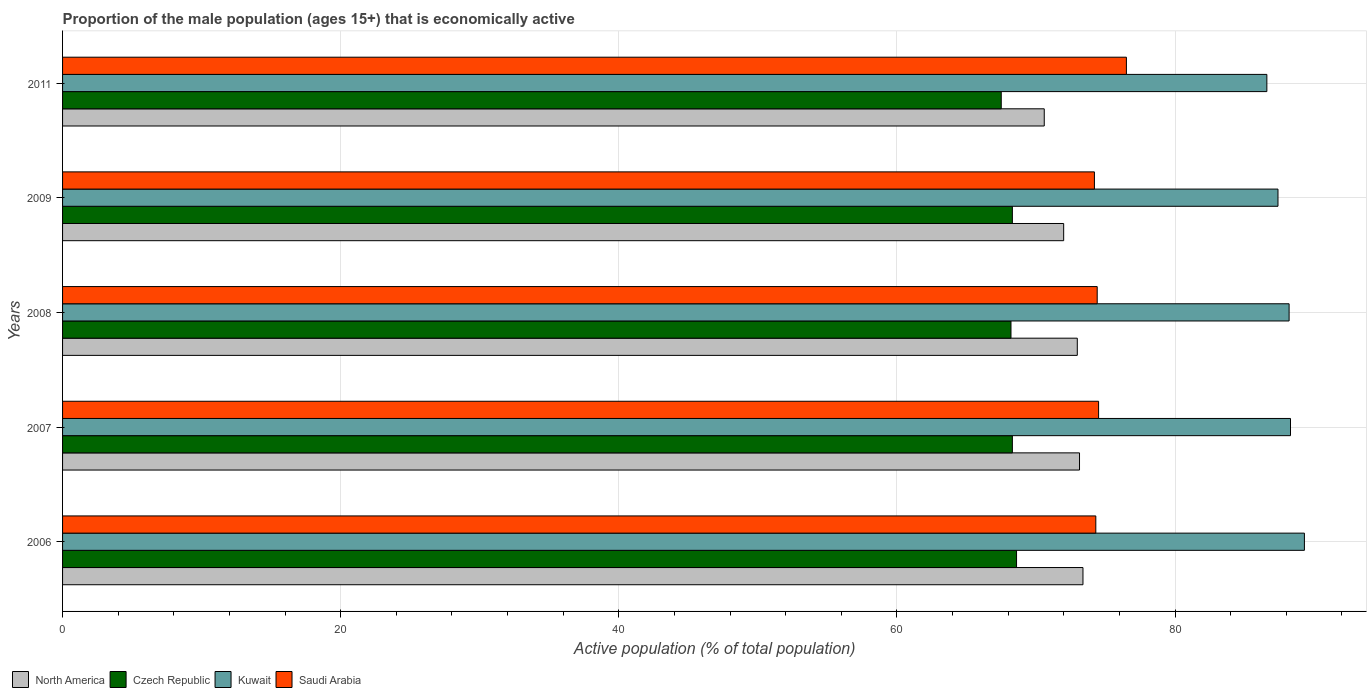How many groups of bars are there?
Offer a terse response. 5. Are the number of bars per tick equal to the number of legend labels?
Make the answer very short. Yes. How many bars are there on the 4th tick from the bottom?
Make the answer very short. 4. In how many cases, is the number of bars for a given year not equal to the number of legend labels?
Offer a very short reply. 0. What is the proportion of the male population that is economically active in Kuwait in 2006?
Offer a terse response. 89.3. Across all years, what is the maximum proportion of the male population that is economically active in Saudi Arabia?
Give a very brief answer. 76.5. Across all years, what is the minimum proportion of the male population that is economically active in Czech Republic?
Provide a short and direct response. 67.5. In which year was the proportion of the male population that is economically active in Saudi Arabia maximum?
Your response must be concise. 2011. What is the total proportion of the male population that is economically active in North America in the graph?
Your answer should be compact. 362.06. What is the difference between the proportion of the male population that is economically active in Czech Republic in 2007 and that in 2008?
Ensure brevity in your answer.  0.1. What is the difference between the proportion of the male population that is economically active in Czech Republic in 2006 and the proportion of the male population that is economically active in Kuwait in 2009?
Offer a very short reply. -18.8. What is the average proportion of the male population that is economically active in North America per year?
Give a very brief answer. 72.41. In the year 2008, what is the difference between the proportion of the male population that is economically active in Kuwait and proportion of the male population that is economically active in North America?
Provide a succinct answer. 15.23. In how many years, is the proportion of the male population that is economically active in Czech Republic greater than 44 %?
Make the answer very short. 5. What is the ratio of the proportion of the male population that is economically active in Kuwait in 2006 to that in 2008?
Offer a terse response. 1.01. What is the difference between the highest and the second highest proportion of the male population that is economically active in Saudi Arabia?
Give a very brief answer. 2. What is the difference between the highest and the lowest proportion of the male population that is economically active in Czech Republic?
Ensure brevity in your answer.  1.1. In how many years, is the proportion of the male population that is economically active in Saudi Arabia greater than the average proportion of the male population that is economically active in Saudi Arabia taken over all years?
Your answer should be very brief. 1. Is the sum of the proportion of the male population that is economically active in North America in 2008 and 2011 greater than the maximum proportion of the male population that is economically active in Czech Republic across all years?
Provide a succinct answer. Yes. Is it the case that in every year, the sum of the proportion of the male population that is economically active in North America and proportion of the male population that is economically active in Czech Republic is greater than the sum of proportion of the male population that is economically active in Kuwait and proportion of the male population that is economically active in Saudi Arabia?
Make the answer very short. No. What does the 3rd bar from the top in 2009 represents?
Offer a very short reply. Czech Republic. What does the 4th bar from the bottom in 2009 represents?
Make the answer very short. Saudi Arabia. Are all the bars in the graph horizontal?
Your answer should be very brief. Yes. Are the values on the major ticks of X-axis written in scientific E-notation?
Provide a succinct answer. No. Does the graph contain grids?
Make the answer very short. Yes. Where does the legend appear in the graph?
Make the answer very short. Bottom left. How many legend labels are there?
Your response must be concise. 4. What is the title of the graph?
Keep it short and to the point. Proportion of the male population (ages 15+) that is economically active. What is the label or title of the X-axis?
Ensure brevity in your answer.  Active population (% of total population). What is the Active population (% of total population) in North America in 2006?
Provide a short and direct response. 73.38. What is the Active population (% of total population) of Czech Republic in 2006?
Give a very brief answer. 68.6. What is the Active population (% of total population) of Kuwait in 2006?
Offer a terse response. 89.3. What is the Active population (% of total population) in Saudi Arabia in 2006?
Give a very brief answer. 74.3. What is the Active population (% of total population) of North America in 2007?
Provide a short and direct response. 73.13. What is the Active population (% of total population) of Czech Republic in 2007?
Give a very brief answer. 68.3. What is the Active population (% of total population) of Kuwait in 2007?
Ensure brevity in your answer.  88.3. What is the Active population (% of total population) of Saudi Arabia in 2007?
Keep it short and to the point. 74.5. What is the Active population (% of total population) in North America in 2008?
Provide a succinct answer. 72.97. What is the Active population (% of total population) of Czech Republic in 2008?
Your answer should be very brief. 68.2. What is the Active population (% of total population) in Kuwait in 2008?
Make the answer very short. 88.2. What is the Active population (% of total population) of Saudi Arabia in 2008?
Your answer should be compact. 74.4. What is the Active population (% of total population) of North America in 2009?
Make the answer very short. 71.99. What is the Active population (% of total population) in Czech Republic in 2009?
Your answer should be compact. 68.3. What is the Active population (% of total population) in Kuwait in 2009?
Offer a very short reply. 87.4. What is the Active population (% of total population) in Saudi Arabia in 2009?
Your answer should be very brief. 74.2. What is the Active population (% of total population) of North America in 2011?
Keep it short and to the point. 70.59. What is the Active population (% of total population) of Czech Republic in 2011?
Offer a terse response. 67.5. What is the Active population (% of total population) in Kuwait in 2011?
Offer a terse response. 86.6. What is the Active population (% of total population) in Saudi Arabia in 2011?
Your response must be concise. 76.5. Across all years, what is the maximum Active population (% of total population) of North America?
Your answer should be compact. 73.38. Across all years, what is the maximum Active population (% of total population) in Czech Republic?
Keep it short and to the point. 68.6. Across all years, what is the maximum Active population (% of total population) of Kuwait?
Offer a terse response. 89.3. Across all years, what is the maximum Active population (% of total population) in Saudi Arabia?
Make the answer very short. 76.5. Across all years, what is the minimum Active population (% of total population) in North America?
Your answer should be very brief. 70.59. Across all years, what is the minimum Active population (% of total population) in Czech Republic?
Your response must be concise. 67.5. Across all years, what is the minimum Active population (% of total population) in Kuwait?
Provide a succinct answer. 86.6. Across all years, what is the minimum Active population (% of total population) in Saudi Arabia?
Give a very brief answer. 74.2. What is the total Active population (% of total population) in North America in the graph?
Give a very brief answer. 362.06. What is the total Active population (% of total population) of Czech Republic in the graph?
Offer a very short reply. 340.9. What is the total Active population (% of total population) of Kuwait in the graph?
Keep it short and to the point. 439.8. What is the total Active population (% of total population) in Saudi Arabia in the graph?
Provide a succinct answer. 373.9. What is the difference between the Active population (% of total population) of North America in 2006 and that in 2007?
Ensure brevity in your answer.  0.25. What is the difference between the Active population (% of total population) in Saudi Arabia in 2006 and that in 2007?
Provide a succinct answer. -0.2. What is the difference between the Active population (% of total population) in North America in 2006 and that in 2008?
Provide a short and direct response. 0.41. What is the difference between the Active population (% of total population) of Kuwait in 2006 and that in 2008?
Provide a succinct answer. 1.1. What is the difference between the Active population (% of total population) in Saudi Arabia in 2006 and that in 2008?
Provide a succinct answer. -0.1. What is the difference between the Active population (% of total population) of North America in 2006 and that in 2009?
Your response must be concise. 1.39. What is the difference between the Active population (% of total population) of Czech Republic in 2006 and that in 2009?
Your answer should be very brief. 0.3. What is the difference between the Active population (% of total population) of North America in 2006 and that in 2011?
Provide a succinct answer. 2.78. What is the difference between the Active population (% of total population) in Czech Republic in 2006 and that in 2011?
Provide a short and direct response. 1.1. What is the difference between the Active population (% of total population) of Saudi Arabia in 2006 and that in 2011?
Your response must be concise. -2.2. What is the difference between the Active population (% of total population) in North America in 2007 and that in 2008?
Your answer should be very brief. 0.16. What is the difference between the Active population (% of total population) of Czech Republic in 2007 and that in 2008?
Provide a short and direct response. 0.1. What is the difference between the Active population (% of total population) in Saudi Arabia in 2007 and that in 2008?
Keep it short and to the point. 0.1. What is the difference between the Active population (% of total population) of North America in 2007 and that in 2009?
Offer a terse response. 1.14. What is the difference between the Active population (% of total population) in Czech Republic in 2007 and that in 2009?
Your answer should be compact. 0. What is the difference between the Active population (% of total population) in Kuwait in 2007 and that in 2009?
Your response must be concise. 0.9. What is the difference between the Active population (% of total population) in North America in 2007 and that in 2011?
Make the answer very short. 2.54. What is the difference between the Active population (% of total population) in North America in 2008 and that in 2009?
Your answer should be very brief. 0.98. What is the difference between the Active population (% of total population) of Saudi Arabia in 2008 and that in 2009?
Your answer should be very brief. 0.2. What is the difference between the Active population (% of total population) of North America in 2008 and that in 2011?
Offer a very short reply. 2.38. What is the difference between the Active population (% of total population) of Saudi Arabia in 2008 and that in 2011?
Make the answer very short. -2.1. What is the difference between the Active population (% of total population) in North America in 2009 and that in 2011?
Offer a terse response. 1.4. What is the difference between the Active population (% of total population) in North America in 2006 and the Active population (% of total population) in Czech Republic in 2007?
Your response must be concise. 5.08. What is the difference between the Active population (% of total population) of North America in 2006 and the Active population (% of total population) of Kuwait in 2007?
Your answer should be compact. -14.92. What is the difference between the Active population (% of total population) of North America in 2006 and the Active population (% of total population) of Saudi Arabia in 2007?
Give a very brief answer. -1.12. What is the difference between the Active population (% of total population) in Czech Republic in 2006 and the Active population (% of total population) in Kuwait in 2007?
Give a very brief answer. -19.7. What is the difference between the Active population (% of total population) in Czech Republic in 2006 and the Active population (% of total population) in Saudi Arabia in 2007?
Keep it short and to the point. -5.9. What is the difference between the Active population (% of total population) of Kuwait in 2006 and the Active population (% of total population) of Saudi Arabia in 2007?
Keep it short and to the point. 14.8. What is the difference between the Active population (% of total population) of North America in 2006 and the Active population (% of total population) of Czech Republic in 2008?
Your answer should be compact. 5.18. What is the difference between the Active population (% of total population) of North America in 2006 and the Active population (% of total population) of Kuwait in 2008?
Provide a short and direct response. -14.82. What is the difference between the Active population (% of total population) in North America in 2006 and the Active population (% of total population) in Saudi Arabia in 2008?
Provide a short and direct response. -1.02. What is the difference between the Active population (% of total population) in Czech Republic in 2006 and the Active population (% of total population) in Kuwait in 2008?
Provide a short and direct response. -19.6. What is the difference between the Active population (% of total population) in North America in 2006 and the Active population (% of total population) in Czech Republic in 2009?
Give a very brief answer. 5.08. What is the difference between the Active population (% of total population) of North America in 2006 and the Active population (% of total population) of Kuwait in 2009?
Make the answer very short. -14.02. What is the difference between the Active population (% of total population) in North America in 2006 and the Active population (% of total population) in Saudi Arabia in 2009?
Keep it short and to the point. -0.82. What is the difference between the Active population (% of total population) in Czech Republic in 2006 and the Active population (% of total population) in Kuwait in 2009?
Offer a very short reply. -18.8. What is the difference between the Active population (% of total population) in Kuwait in 2006 and the Active population (% of total population) in Saudi Arabia in 2009?
Keep it short and to the point. 15.1. What is the difference between the Active population (% of total population) of North America in 2006 and the Active population (% of total population) of Czech Republic in 2011?
Offer a terse response. 5.88. What is the difference between the Active population (% of total population) of North America in 2006 and the Active population (% of total population) of Kuwait in 2011?
Provide a short and direct response. -13.22. What is the difference between the Active population (% of total population) in North America in 2006 and the Active population (% of total population) in Saudi Arabia in 2011?
Your response must be concise. -3.12. What is the difference between the Active population (% of total population) of Czech Republic in 2006 and the Active population (% of total population) of Kuwait in 2011?
Offer a very short reply. -18. What is the difference between the Active population (% of total population) in Kuwait in 2006 and the Active population (% of total population) in Saudi Arabia in 2011?
Keep it short and to the point. 12.8. What is the difference between the Active population (% of total population) of North America in 2007 and the Active population (% of total population) of Czech Republic in 2008?
Give a very brief answer. 4.93. What is the difference between the Active population (% of total population) in North America in 2007 and the Active population (% of total population) in Kuwait in 2008?
Offer a terse response. -15.07. What is the difference between the Active population (% of total population) in North America in 2007 and the Active population (% of total population) in Saudi Arabia in 2008?
Your answer should be very brief. -1.27. What is the difference between the Active population (% of total population) of Czech Republic in 2007 and the Active population (% of total population) of Kuwait in 2008?
Keep it short and to the point. -19.9. What is the difference between the Active population (% of total population) of Kuwait in 2007 and the Active population (% of total population) of Saudi Arabia in 2008?
Your answer should be very brief. 13.9. What is the difference between the Active population (% of total population) of North America in 2007 and the Active population (% of total population) of Czech Republic in 2009?
Keep it short and to the point. 4.83. What is the difference between the Active population (% of total population) in North America in 2007 and the Active population (% of total population) in Kuwait in 2009?
Your answer should be very brief. -14.27. What is the difference between the Active population (% of total population) of North America in 2007 and the Active population (% of total population) of Saudi Arabia in 2009?
Provide a succinct answer. -1.07. What is the difference between the Active population (% of total population) of Czech Republic in 2007 and the Active population (% of total population) of Kuwait in 2009?
Ensure brevity in your answer.  -19.1. What is the difference between the Active population (% of total population) of North America in 2007 and the Active population (% of total population) of Czech Republic in 2011?
Keep it short and to the point. 5.63. What is the difference between the Active population (% of total population) of North America in 2007 and the Active population (% of total population) of Kuwait in 2011?
Make the answer very short. -13.47. What is the difference between the Active population (% of total population) in North America in 2007 and the Active population (% of total population) in Saudi Arabia in 2011?
Keep it short and to the point. -3.37. What is the difference between the Active population (% of total population) in Czech Republic in 2007 and the Active population (% of total population) in Kuwait in 2011?
Ensure brevity in your answer.  -18.3. What is the difference between the Active population (% of total population) in Czech Republic in 2007 and the Active population (% of total population) in Saudi Arabia in 2011?
Ensure brevity in your answer.  -8.2. What is the difference between the Active population (% of total population) in North America in 2008 and the Active population (% of total population) in Czech Republic in 2009?
Your response must be concise. 4.67. What is the difference between the Active population (% of total population) in North America in 2008 and the Active population (% of total population) in Kuwait in 2009?
Your answer should be very brief. -14.43. What is the difference between the Active population (% of total population) of North America in 2008 and the Active population (% of total population) of Saudi Arabia in 2009?
Your answer should be very brief. -1.23. What is the difference between the Active population (% of total population) of Czech Republic in 2008 and the Active population (% of total population) of Kuwait in 2009?
Make the answer very short. -19.2. What is the difference between the Active population (% of total population) of Czech Republic in 2008 and the Active population (% of total population) of Saudi Arabia in 2009?
Your answer should be compact. -6. What is the difference between the Active population (% of total population) in North America in 2008 and the Active population (% of total population) in Czech Republic in 2011?
Provide a short and direct response. 5.47. What is the difference between the Active population (% of total population) in North America in 2008 and the Active population (% of total population) in Kuwait in 2011?
Give a very brief answer. -13.63. What is the difference between the Active population (% of total population) in North America in 2008 and the Active population (% of total population) in Saudi Arabia in 2011?
Make the answer very short. -3.53. What is the difference between the Active population (% of total population) of Czech Republic in 2008 and the Active population (% of total population) of Kuwait in 2011?
Give a very brief answer. -18.4. What is the difference between the Active population (% of total population) in Kuwait in 2008 and the Active population (% of total population) in Saudi Arabia in 2011?
Keep it short and to the point. 11.7. What is the difference between the Active population (% of total population) of North America in 2009 and the Active population (% of total population) of Czech Republic in 2011?
Your answer should be very brief. 4.49. What is the difference between the Active population (% of total population) in North America in 2009 and the Active population (% of total population) in Kuwait in 2011?
Provide a succinct answer. -14.61. What is the difference between the Active population (% of total population) of North America in 2009 and the Active population (% of total population) of Saudi Arabia in 2011?
Offer a terse response. -4.51. What is the difference between the Active population (% of total population) in Czech Republic in 2009 and the Active population (% of total population) in Kuwait in 2011?
Offer a very short reply. -18.3. What is the difference between the Active population (% of total population) of Czech Republic in 2009 and the Active population (% of total population) of Saudi Arabia in 2011?
Your response must be concise. -8.2. What is the difference between the Active population (% of total population) in Kuwait in 2009 and the Active population (% of total population) in Saudi Arabia in 2011?
Your response must be concise. 10.9. What is the average Active population (% of total population) in North America per year?
Provide a short and direct response. 72.41. What is the average Active population (% of total population) in Czech Republic per year?
Your answer should be very brief. 68.18. What is the average Active population (% of total population) of Kuwait per year?
Your answer should be compact. 87.96. What is the average Active population (% of total population) in Saudi Arabia per year?
Offer a terse response. 74.78. In the year 2006, what is the difference between the Active population (% of total population) in North America and Active population (% of total population) in Czech Republic?
Provide a short and direct response. 4.78. In the year 2006, what is the difference between the Active population (% of total population) of North America and Active population (% of total population) of Kuwait?
Offer a very short reply. -15.92. In the year 2006, what is the difference between the Active population (% of total population) of North America and Active population (% of total population) of Saudi Arabia?
Ensure brevity in your answer.  -0.92. In the year 2006, what is the difference between the Active population (% of total population) of Czech Republic and Active population (% of total population) of Kuwait?
Your answer should be compact. -20.7. In the year 2006, what is the difference between the Active population (% of total population) in Kuwait and Active population (% of total population) in Saudi Arabia?
Your answer should be very brief. 15. In the year 2007, what is the difference between the Active population (% of total population) of North America and Active population (% of total population) of Czech Republic?
Your answer should be compact. 4.83. In the year 2007, what is the difference between the Active population (% of total population) of North America and Active population (% of total population) of Kuwait?
Your response must be concise. -15.17. In the year 2007, what is the difference between the Active population (% of total population) in North America and Active population (% of total population) in Saudi Arabia?
Make the answer very short. -1.37. In the year 2007, what is the difference between the Active population (% of total population) of Czech Republic and Active population (% of total population) of Kuwait?
Keep it short and to the point. -20. In the year 2008, what is the difference between the Active population (% of total population) of North America and Active population (% of total population) of Czech Republic?
Your answer should be very brief. 4.77. In the year 2008, what is the difference between the Active population (% of total population) in North America and Active population (% of total population) in Kuwait?
Provide a short and direct response. -15.23. In the year 2008, what is the difference between the Active population (% of total population) in North America and Active population (% of total population) in Saudi Arabia?
Provide a succinct answer. -1.43. In the year 2008, what is the difference between the Active population (% of total population) in Czech Republic and Active population (% of total population) in Kuwait?
Your response must be concise. -20. In the year 2009, what is the difference between the Active population (% of total population) of North America and Active population (% of total population) of Czech Republic?
Provide a short and direct response. 3.69. In the year 2009, what is the difference between the Active population (% of total population) in North America and Active population (% of total population) in Kuwait?
Offer a very short reply. -15.41. In the year 2009, what is the difference between the Active population (% of total population) in North America and Active population (% of total population) in Saudi Arabia?
Ensure brevity in your answer.  -2.21. In the year 2009, what is the difference between the Active population (% of total population) of Czech Republic and Active population (% of total population) of Kuwait?
Make the answer very short. -19.1. In the year 2011, what is the difference between the Active population (% of total population) in North America and Active population (% of total population) in Czech Republic?
Make the answer very short. 3.09. In the year 2011, what is the difference between the Active population (% of total population) in North America and Active population (% of total population) in Kuwait?
Keep it short and to the point. -16.01. In the year 2011, what is the difference between the Active population (% of total population) of North America and Active population (% of total population) of Saudi Arabia?
Keep it short and to the point. -5.91. In the year 2011, what is the difference between the Active population (% of total population) of Czech Republic and Active population (% of total population) of Kuwait?
Offer a terse response. -19.1. In the year 2011, what is the difference between the Active population (% of total population) in Czech Republic and Active population (% of total population) in Saudi Arabia?
Offer a terse response. -9. In the year 2011, what is the difference between the Active population (% of total population) in Kuwait and Active population (% of total population) in Saudi Arabia?
Your response must be concise. 10.1. What is the ratio of the Active population (% of total population) of Czech Republic in 2006 to that in 2007?
Keep it short and to the point. 1. What is the ratio of the Active population (% of total population) of Kuwait in 2006 to that in 2007?
Make the answer very short. 1.01. What is the ratio of the Active population (% of total population) in Saudi Arabia in 2006 to that in 2007?
Provide a short and direct response. 1. What is the ratio of the Active population (% of total population) in North America in 2006 to that in 2008?
Your response must be concise. 1.01. What is the ratio of the Active population (% of total population) of Czech Republic in 2006 to that in 2008?
Make the answer very short. 1.01. What is the ratio of the Active population (% of total population) in Kuwait in 2006 to that in 2008?
Offer a terse response. 1.01. What is the ratio of the Active population (% of total population) of North America in 2006 to that in 2009?
Provide a succinct answer. 1.02. What is the ratio of the Active population (% of total population) in Czech Republic in 2006 to that in 2009?
Keep it short and to the point. 1. What is the ratio of the Active population (% of total population) in Kuwait in 2006 to that in 2009?
Keep it short and to the point. 1.02. What is the ratio of the Active population (% of total population) of Saudi Arabia in 2006 to that in 2009?
Your response must be concise. 1. What is the ratio of the Active population (% of total population) of North America in 2006 to that in 2011?
Offer a terse response. 1.04. What is the ratio of the Active population (% of total population) of Czech Republic in 2006 to that in 2011?
Provide a succinct answer. 1.02. What is the ratio of the Active population (% of total population) in Kuwait in 2006 to that in 2011?
Keep it short and to the point. 1.03. What is the ratio of the Active population (% of total population) of Saudi Arabia in 2006 to that in 2011?
Provide a succinct answer. 0.97. What is the ratio of the Active population (% of total population) of Czech Republic in 2007 to that in 2008?
Make the answer very short. 1. What is the ratio of the Active population (% of total population) of North America in 2007 to that in 2009?
Give a very brief answer. 1.02. What is the ratio of the Active population (% of total population) of Kuwait in 2007 to that in 2009?
Make the answer very short. 1.01. What is the ratio of the Active population (% of total population) of Saudi Arabia in 2007 to that in 2009?
Offer a terse response. 1. What is the ratio of the Active population (% of total population) in North America in 2007 to that in 2011?
Make the answer very short. 1.04. What is the ratio of the Active population (% of total population) of Czech Republic in 2007 to that in 2011?
Ensure brevity in your answer.  1.01. What is the ratio of the Active population (% of total population) in Kuwait in 2007 to that in 2011?
Keep it short and to the point. 1.02. What is the ratio of the Active population (% of total population) in Saudi Arabia in 2007 to that in 2011?
Offer a terse response. 0.97. What is the ratio of the Active population (% of total population) of North America in 2008 to that in 2009?
Provide a succinct answer. 1.01. What is the ratio of the Active population (% of total population) in Kuwait in 2008 to that in 2009?
Your answer should be very brief. 1.01. What is the ratio of the Active population (% of total population) in Saudi Arabia in 2008 to that in 2009?
Keep it short and to the point. 1. What is the ratio of the Active population (% of total population) of North America in 2008 to that in 2011?
Ensure brevity in your answer.  1.03. What is the ratio of the Active population (% of total population) in Czech Republic in 2008 to that in 2011?
Keep it short and to the point. 1.01. What is the ratio of the Active population (% of total population) of Kuwait in 2008 to that in 2011?
Make the answer very short. 1.02. What is the ratio of the Active population (% of total population) in Saudi Arabia in 2008 to that in 2011?
Keep it short and to the point. 0.97. What is the ratio of the Active population (% of total population) of North America in 2009 to that in 2011?
Offer a terse response. 1.02. What is the ratio of the Active population (% of total population) in Czech Republic in 2009 to that in 2011?
Offer a very short reply. 1.01. What is the ratio of the Active population (% of total population) of Kuwait in 2009 to that in 2011?
Your answer should be very brief. 1.01. What is the ratio of the Active population (% of total population) of Saudi Arabia in 2009 to that in 2011?
Provide a succinct answer. 0.97. What is the difference between the highest and the second highest Active population (% of total population) in North America?
Ensure brevity in your answer.  0.25. What is the difference between the highest and the second highest Active population (% of total population) of Czech Republic?
Give a very brief answer. 0.3. What is the difference between the highest and the second highest Active population (% of total population) in Saudi Arabia?
Your response must be concise. 2. What is the difference between the highest and the lowest Active population (% of total population) in North America?
Your response must be concise. 2.78. What is the difference between the highest and the lowest Active population (% of total population) of Czech Republic?
Keep it short and to the point. 1.1. What is the difference between the highest and the lowest Active population (% of total population) in Kuwait?
Make the answer very short. 2.7. What is the difference between the highest and the lowest Active population (% of total population) in Saudi Arabia?
Provide a short and direct response. 2.3. 